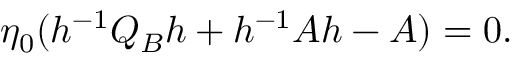Convert formula to latex. <formula><loc_0><loc_0><loc_500><loc_500>\eta _ { 0 } ( h ^ { - 1 } Q _ { B } h + h ^ { - 1 } A h - A ) = 0 .</formula> 